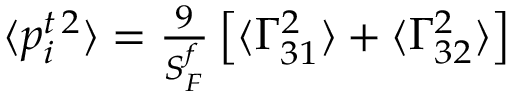Convert formula to latex. <formula><loc_0><loc_0><loc_500><loc_500>\begin{array} { r } { \langle p _ { i } ^ { t \, 2 } \rangle = \frac { 9 } { S _ { F } ^ { f } } \left [ \langle \Gamma _ { 3 1 } ^ { 2 } \rangle + \langle \Gamma _ { 3 2 } ^ { 2 } \rangle \right ] } \end{array}</formula> 